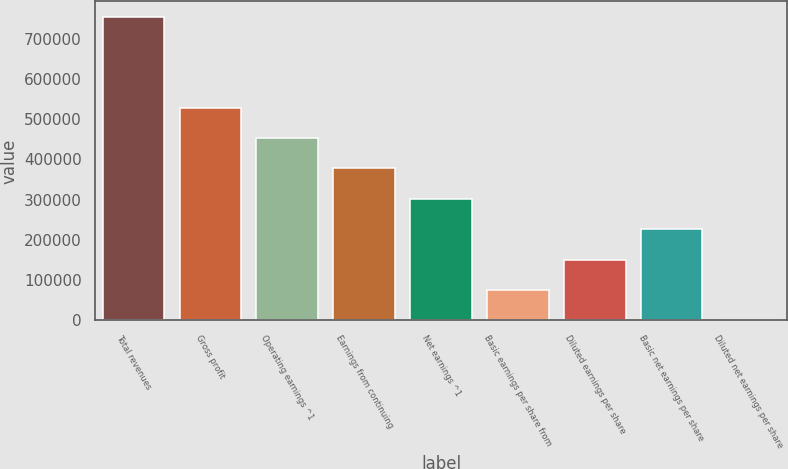Convert chart to OTSL. <chart><loc_0><loc_0><loc_500><loc_500><bar_chart><fcel>Total revenues<fcel>Gross profit<fcel>Operating earnings ^1<fcel>Earnings from continuing<fcel>Net earnings ^1<fcel>Basic earnings per share from<fcel>Diluted earnings per share<fcel>Basic net earnings per share<fcel>Diluted net earnings per share<nl><fcel>755027<fcel>528519<fcel>453016<fcel>377514<fcel>302011<fcel>75502.9<fcel>151006<fcel>226508<fcel>0.28<nl></chart> 